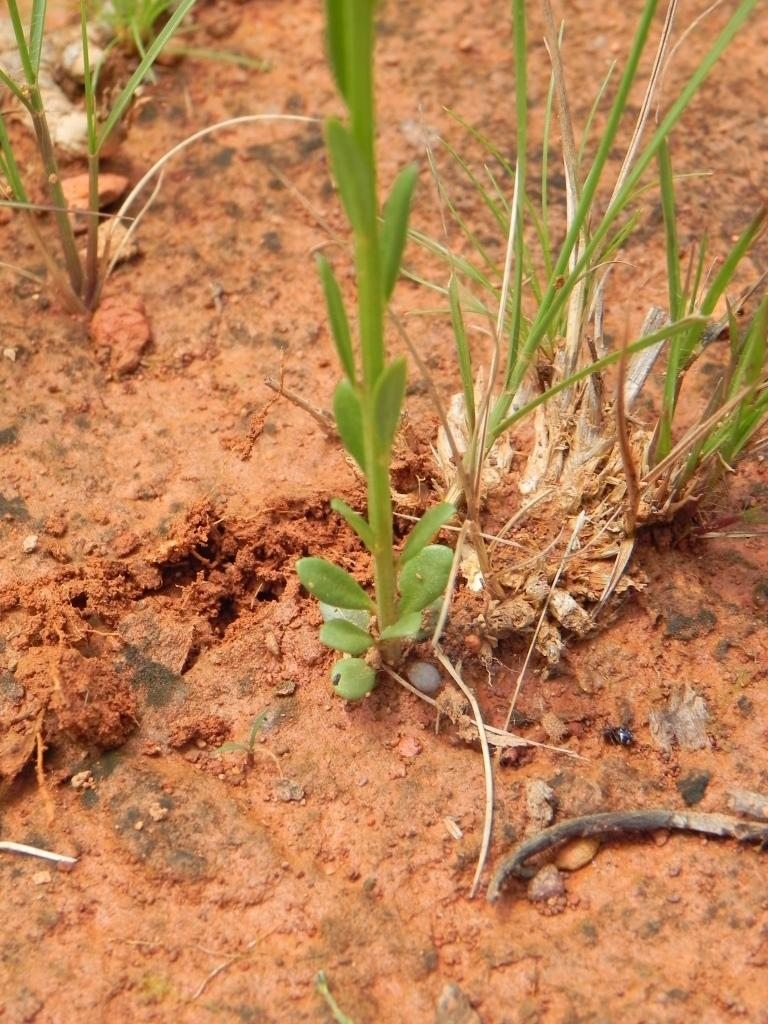What type of living organisms can be seen in the image? Plants can be seen in the image. What else is present on the ground in the image? There are other objects on the ground in the image. What is the taste of the quartz in the image? There is no quartz present in the image, so it cannot be tasted. 